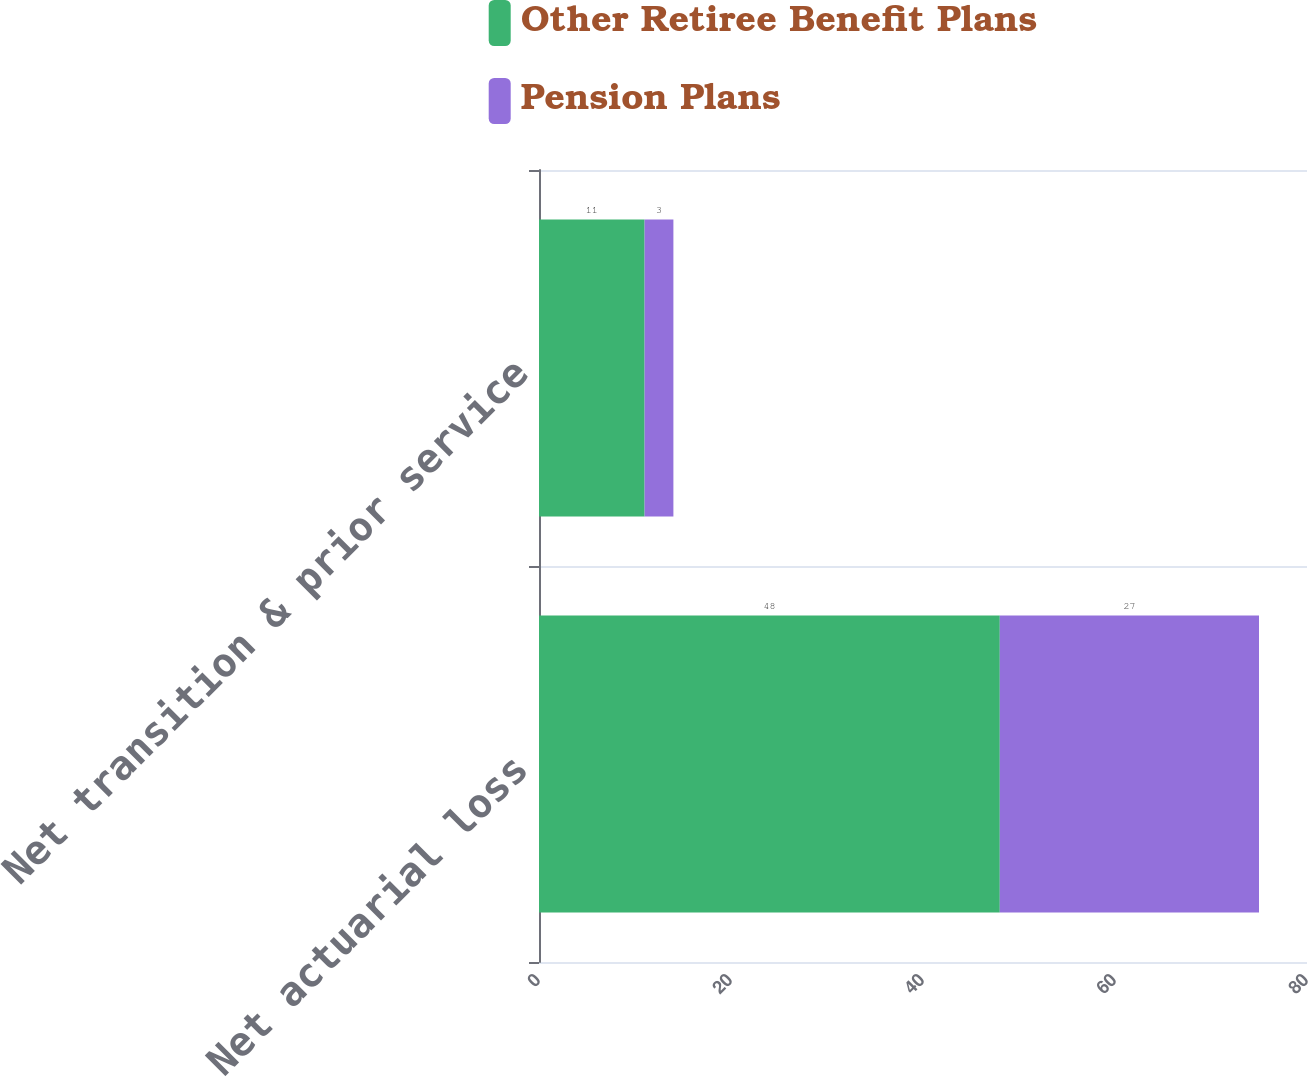<chart> <loc_0><loc_0><loc_500><loc_500><stacked_bar_chart><ecel><fcel>Net actuarial loss<fcel>Net transition & prior service<nl><fcel>Other Retiree Benefit Plans<fcel>48<fcel>11<nl><fcel>Pension Plans<fcel>27<fcel>3<nl></chart> 